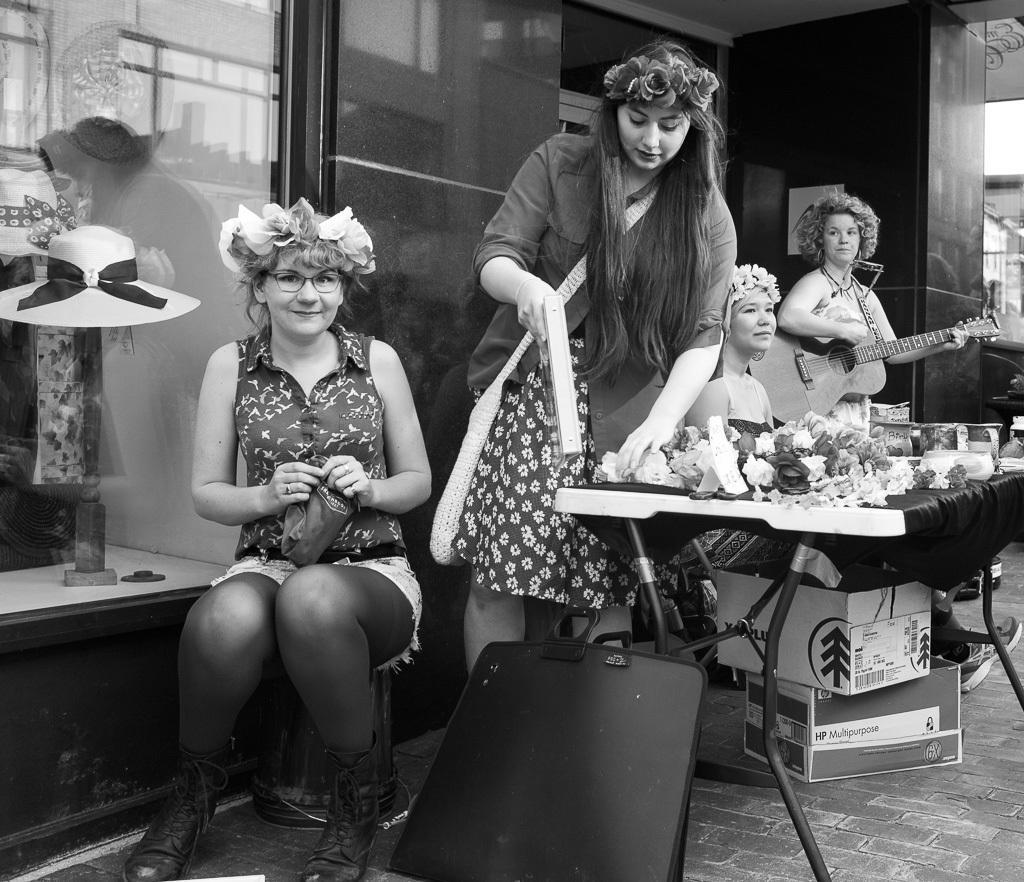Please provide a concise description of this image. In this image there are two persons sitting, two persons standing, flowers and some objects on the table, a person holding a guitar , there are cardboard boxes, neck mannequin,hats, houses. 